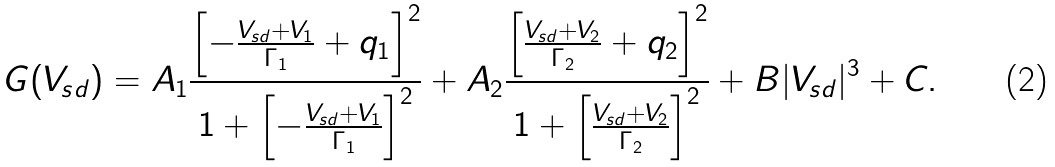<formula> <loc_0><loc_0><loc_500><loc_500>G ( V _ { s d } ) = A _ { 1 } \frac { \left [ - \frac { V _ { s d } + V _ { 1 } } { \Gamma _ { 1 } } + q _ { 1 } \right ] ^ { 2 } } { 1 + \left [ - \frac { V _ { s d } + V _ { 1 } } { \Gamma _ { 1 } } \right ] ^ { 2 } } + A _ { 2 } \frac { \left [ \frac { V _ { s d } + V _ { 2 } } { \Gamma _ { 2 } } + q _ { 2 } \right ] ^ { 2 } } { 1 + \left [ \frac { V _ { s d } + V _ { 2 } } { \Gamma _ { 2 } } \right ] ^ { 2 } } + B | V _ { s d } | ^ { 3 } + C .</formula> 